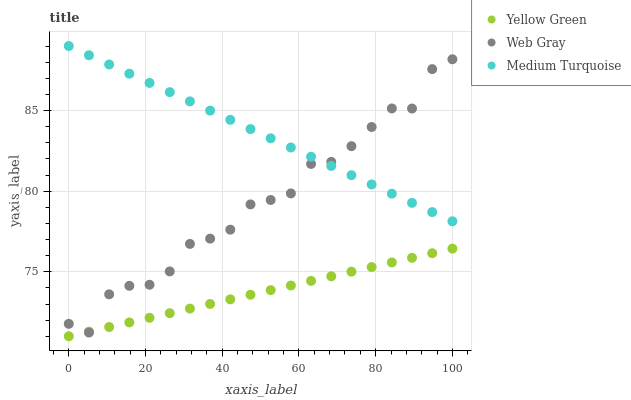Does Yellow Green have the minimum area under the curve?
Answer yes or no. Yes. Does Medium Turquoise have the maximum area under the curve?
Answer yes or no. Yes. Does Medium Turquoise have the minimum area under the curve?
Answer yes or no. No. Does Yellow Green have the maximum area under the curve?
Answer yes or no. No. Is Medium Turquoise the smoothest?
Answer yes or no. Yes. Is Web Gray the roughest?
Answer yes or no. Yes. Is Yellow Green the smoothest?
Answer yes or no. No. Is Yellow Green the roughest?
Answer yes or no. No. Does Yellow Green have the lowest value?
Answer yes or no. Yes. Does Medium Turquoise have the lowest value?
Answer yes or no. No. Does Medium Turquoise have the highest value?
Answer yes or no. Yes. Does Yellow Green have the highest value?
Answer yes or no. No. Is Yellow Green less than Medium Turquoise?
Answer yes or no. Yes. Is Medium Turquoise greater than Yellow Green?
Answer yes or no. Yes. Does Web Gray intersect Yellow Green?
Answer yes or no. Yes. Is Web Gray less than Yellow Green?
Answer yes or no. No. Is Web Gray greater than Yellow Green?
Answer yes or no. No. Does Yellow Green intersect Medium Turquoise?
Answer yes or no. No. 